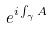Convert formula to latex. <formula><loc_0><loc_0><loc_500><loc_500>e ^ { i \int _ { \gamma } A }</formula> 